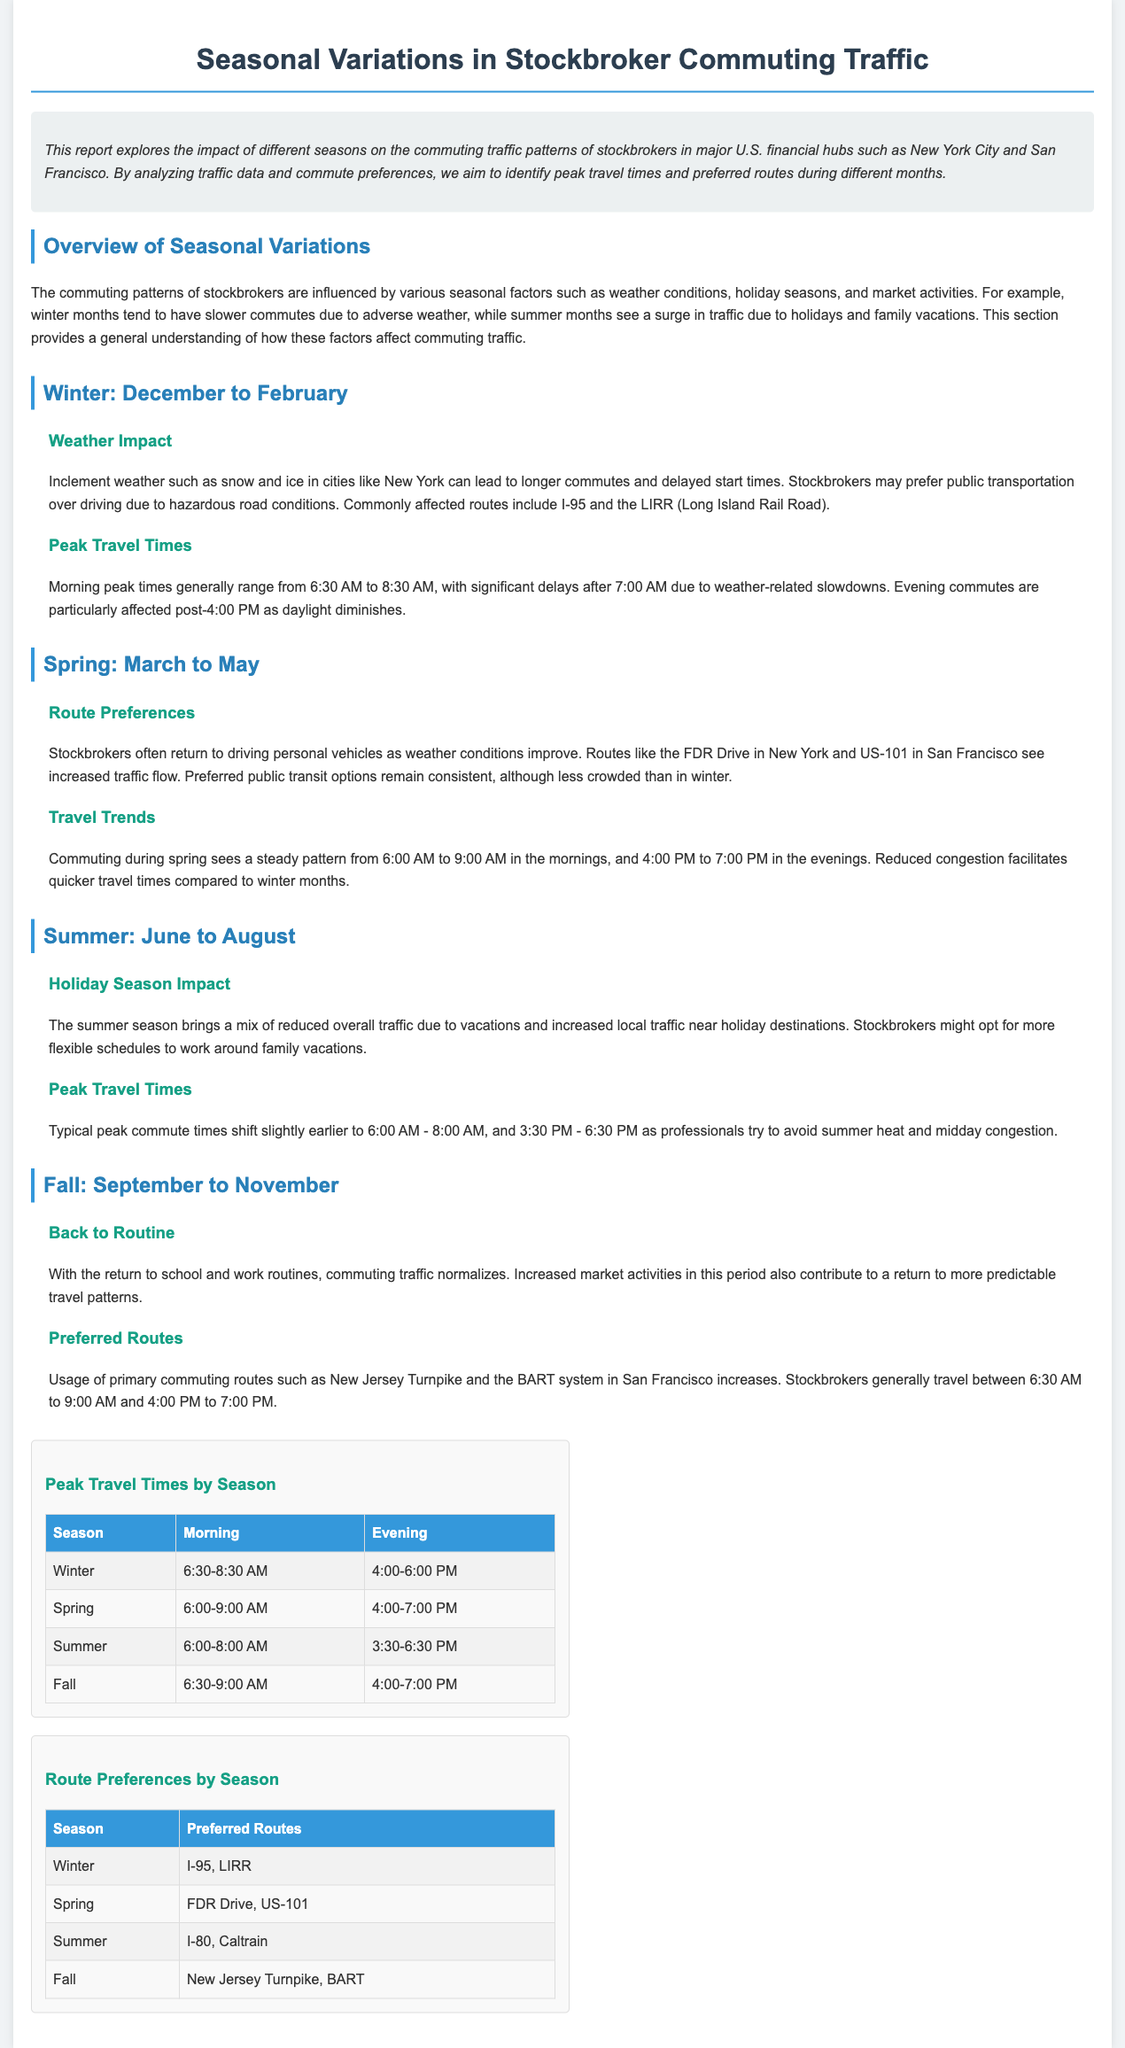What are the peak morning travel times in winter? The peak morning travel times for winter are detailed in the visual data table, which shows that morning times generally range from 6:30 AM to 8:30 AM.
Answer: 6:30-8:30 AM What routes do stockbrokers prefer in spring? The report provides a visual data table listing preferred routes, which for spring are indicated as the FDR Drive and US-101.
Answer: FDR Drive, US-101 What season sees the highest evening peak travel times? By examining the peak travel times for each season, it is clear that summer shows the highest evening peak travel times ranging from 3:30 PM to 6:30 PM.
Answer: Summer What is the impact of the holiday season on commuting traffic in summer? The report explains that the summer season brings a mix of reduced overall traffic due to vacations and increased local traffic near holiday destinations.
Answer: Reduced overall traffic What are preferred commuting routes in winter? The visual data table specifies that stockbrokers prefer routes such as I-95 and the LIRR during winter.
Answer: I-95, LIRR What is the time range for evening commutes in fall? The evening commute times in fall are identified in the visual data, which indicates they range from 4:00 PM to 7:00 PM.
Answer: 4:00-7:00 PM Which season shows the earliest typical peak commute times? By analyzing the peak travel times across seasons, it becomes evident that summer has the earliest typical peak commute times of 6:00 AM to 8:00 AM.
Answer: Summer What is the normal commuting pattern during fall? The report states that commuting traffic normalizes during fall due to the return to school and work routines, as well as increased market activities.
Answer: Normalizes 